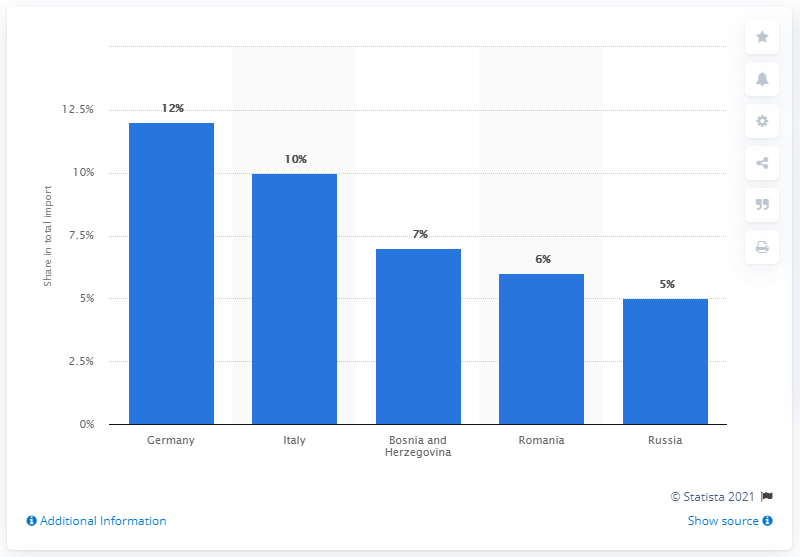Point out several critical features in this image. In 2019, Serbia's most important import partner was Germany. 